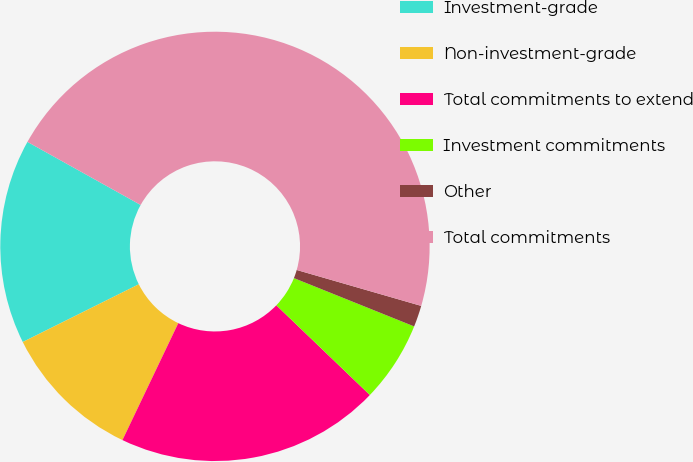Convert chart to OTSL. <chart><loc_0><loc_0><loc_500><loc_500><pie_chart><fcel>Investment-grade<fcel>Non-investment-grade<fcel>Total commitments to extend<fcel>Investment commitments<fcel>Other<fcel>Total commitments<nl><fcel>15.44%<fcel>10.56%<fcel>19.92%<fcel>6.09%<fcel>1.61%<fcel>46.38%<nl></chart> 